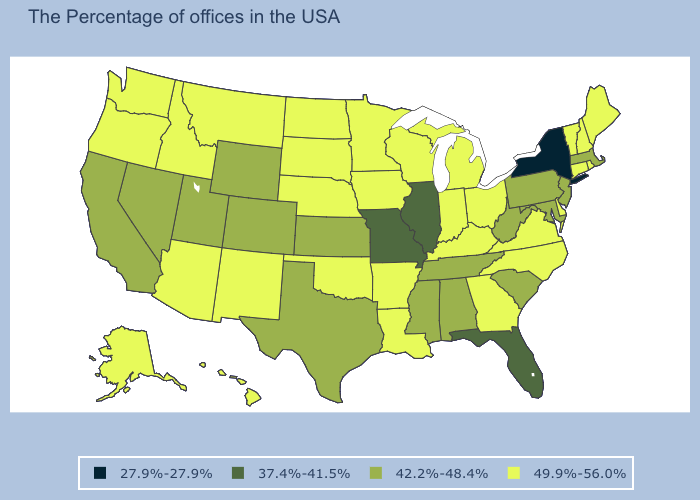Does Florida have the same value as Missouri?
Give a very brief answer. Yes. Which states have the highest value in the USA?
Write a very short answer. Maine, Rhode Island, New Hampshire, Vermont, Connecticut, Delaware, Virginia, North Carolina, Ohio, Georgia, Michigan, Kentucky, Indiana, Wisconsin, Louisiana, Arkansas, Minnesota, Iowa, Nebraska, Oklahoma, South Dakota, North Dakota, New Mexico, Montana, Arizona, Idaho, Washington, Oregon, Alaska, Hawaii. What is the highest value in the USA?
Quick response, please. 49.9%-56.0%. What is the value of Iowa?
Keep it brief. 49.9%-56.0%. What is the value of Minnesota?
Answer briefly. 49.9%-56.0%. Does Michigan have the same value as Arizona?
Quick response, please. Yes. Name the states that have a value in the range 27.9%-27.9%?
Concise answer only. New York. Name the states that have a value in the range 27.9%-27.9%?
Keep it brief. New York. What is the highest value in the USA?
Concise answer only. 49.9%-56.0%. What is the lowest value in the Northeast?
Give a very brief answer. 27.9%-27.9%. Does the first symbol in the legend represent the smallest category?
Answer briefly. Yes. Which states have the lowest value in the Northeast?
Be succinct. New York. What is the value of Montana?
Quick response, please. 49.9%-56.0%. What is the value of New Mexico?
Write a very short answer. 49.9%-56.0%. What is the value of Wisconsin?
Quick response, please. 49.9%-56.0%. 